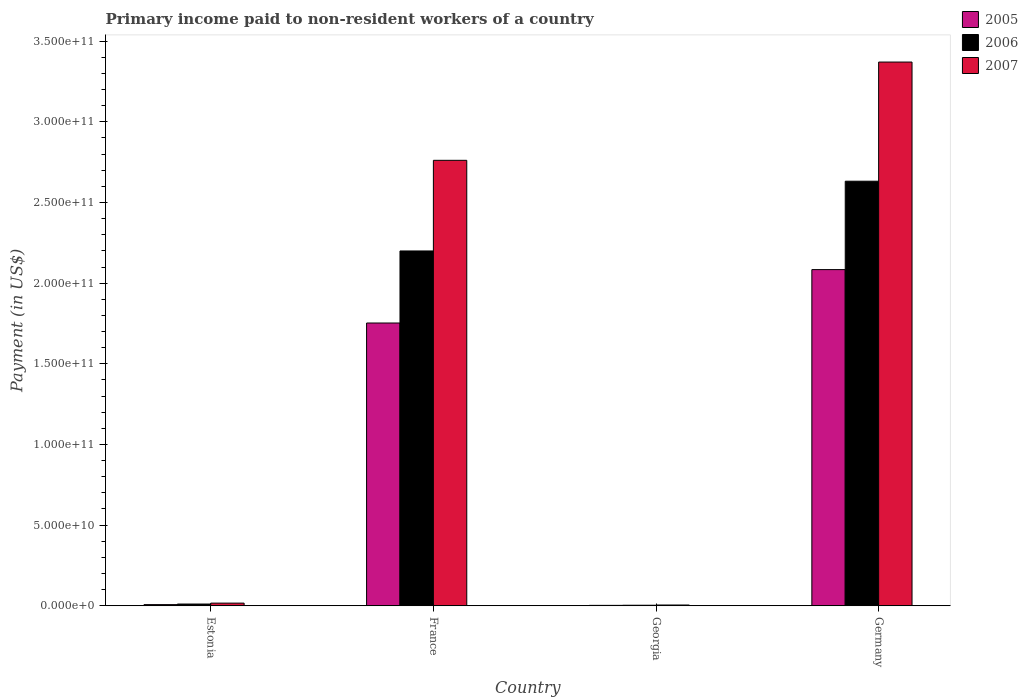Are the number of bars per tick equal to the number of legend labels?
Provide a short and direct response. Yes. How many bars are there on the 4th tick from the right?
Provide a succinct answer. 3. What is the label of the 1st group of bars from the left?
Give a very brief answer. Estonia. In how many cases, is the number of bars for a given country not equal to the number of legend labels?
Give a very brief answer. 0. What is the amount paid to workers in 2006 in Estonia?
Offer a terse response. 1.09e+09. Across all countries, what is the maximum amount paid to workers in 2006?
Provide a short and direct response. 2.63e+11. Across all countries, what is the minimum amount paid to workers in 2005?
Offer a very short reply. 2.63e+08. In which country was the amount paid to workers in 2007 minimum?
Offer a very short reply. Georgia. What is the total amount paid to workers in 2007 in the graph?
Give a very brief answer. 6.15e+11. What is the difference between the amount paid to workers in 2006 in Georgia and that in Germany?
Your response must be concise. -2.63e+11. What is the difference between the amount paid to workers in 2006 in Georgia and the amount paid to workers in 2005 in France?
Offer a terse response. -1.75e+11. What is the average amount paid to workers in 2005 per country?
Offer a terse response. 9.62e+1. What is the difference between the amount paid to workers of/in 2006 and amount paid to workers of/in 2007 in Georgia?
Offer a very short reply. -1.41e+08. What is the ratio of the amount paid to workers in 2006 in France to that in Germany?
Your answer should be very brief. 0.84. What is the difference between the highest and the second highest amount paid to workers in 2007?
Keep it short and to the point. 6.09e+1. What is the difference between the highest and the lowest amount paid to workers in 2007?
Your response must be concise. 3.37e+11. Is the sum of the amount paid to workers in 2005 in Estonia and Georgia greater than the maximum amount paid to workers in 2006 across all countries?
Your response must be concise. No. Is it the case that in every country, the sum of the amount paid to workers in 2005 and amount paid to workers in 2006 is greater than the amount paid to workers in 2007?
Offer a terse response. Yes. Are all the bars in the graph horizontal?
Keep it short and to the point. No. What is the difference between two consecutive major ticks on the Y-axis?
Offer a very short reply. 5.00e+1. Does the graph contain grids?
Make the answer very short. No. Where does the legend appear in the graph?
Provide a short and direct response. Top right. How many legend labels are there?
Your answer should be very brief. 3. What is the title of the graph?
Make the answer very short. Primary income paid to non-resident workers of a country. Does "1992" appear as one of the legend labels in the graph?
Offer a terse response. No. What is the label or title of the Y-axis?
Your answer should be compact. Payment (in US$). What is the Payment (in US$) in 2005 in Estonia?
Make the answer very short. 7.31e+08. What is the Payment (in US$) in 2006 in Estonia?
Offer a terse response. 1.09e+09. What is the Payment (in US$) in 2007 in Estonia?
Provide a succinct answer. 1.66e+09. What is the Payment (in US$) of 2005 in France?
Provide a succinct answer. 1.75e+11. What is the Payment (in US$) of 2006 in France?
Provide a short and direct response. 2.20e+11. What is the Payment (in US$) of 2007 in France?
Provide a short and direct response. 2.76e+11. What is the Payment (in US$) in 2005 in Georgia?
Ensure brevity in your answer.  2.63e+08. What is the Payment (in US$) in 2006 in Georgia?
Keep it short and to the point. 3.41e+08. What is the Payment (in US$) in 2007 in Georgia?
Provide a succinct answer. 4.83e+08. What is the Payment (in US$) of 2005 in Germany?
Provide a succinct answer. 2.08e+11. What is the Payment (in US$) of 2006 in Germany?
Your answer should be very brief. 2.63e+11. What is the Payment (in US$) of 2007 in Germany?
Offer a very short reply. 3.37e+11. Across all countries, what is the maximum Payment (in US$) in 2005?
Your answer should be compact. 2.08e+11. Across all countries, what is the maximum Payment (in US$) in 2006?
Ensure brevity in your answer.  2.63e+11. Across all countries, what is the maximum Payment (in US$) in 2007?
Make the answer very short. 3.37e+11. Across all countries, what is the minimum Payment (in US$) of 2005?
Give a very brief answer. 2.63e+08. Across all countries, what is the minimum Payment (in US$) in 2006?
Give a very brief answer. 3.41e+08. Across all countries, what is the minimum Payment (in US$) in 2007?
Your answer should be very brief. 4.83e+08. What is the total Payment (in US$) of 2005 in the graph?
Your answer should be compact. 3.85e+11. What is the total Payment (in US$) of 2006 in the graph?
Your answer should be very brief. 4.85e+11. What is the total Payment (in US$) in 2007 in the graph?
Your response must be concise. 6.15e+11. What is the difference between the Payment (in US$) in 2005 in Estonia and that in France?
Provide a succinct answer. -1.75e+11. What is the difference between the Payment (in US$) of 2006 in Estonia and that in France?
Offer a terse response. -2.19e+11. What is the difference between the Payment (in US$) of 2007 in Estonia and that in France?
Your answer should be compact. -2.74e+11. What is the difference between the Payment (in US$) of 2005 in Estonia and that in Georgia?
Make the answer very short. 4.67e+08. What is the difference between the Payment (in US$) in 2006 in Estonia and that in Georgia?
Keep it short and to the point. 7.50e+08. What is the difference between the Payment (in US$) in 2007 in Estonia and that in Georgia?
Offer a terse response. 1.18e+09. What is the difference between the Payment (in US$) in 2005 in Estonia and that in Germany?
Offer a terse response. -2.08e+11. What is the difference between the Payment (in US$) in 2006 in Estonia and that in Germany?
Provide a succinct answer. -2.62e+11. What is the difference between the Payment (in US$) in 2007 in Estonia and that in Germany?
Offer a very short reply. -3.35e+11. What is the difference between the Payment (in US$) of 2005 in France and that in Georgia?
Your response must be concise. 1.75e+11. What is the difference between the Payment (in US$) of 2006 in France and that in Georgia?
Your answer should be compact. 2.20e+11. What is the difference between the Payment (in US$) of 2007 in France and that in Georgia?
Your answer should be very brief. 2.76e+11. What is the difference between the Payment (in US$) of 2005 in France and that in Germany?
Ensure brevity in your answer.  -3.31e+1. What is the difference between the Payment (in US$) of 2006 in France and that in Germany?
Your response must be concise. -4.32e+1. What is the difference between the Payment (in US$) of 2007 in France and that in Germany?
Make the answer very short. -6.09e+1. What is the difference between the Payment (in US$) of 2005 in Georgia and that in Germany?
Offer a terse response. -2.08e+11. What is the difference between the Payment (in US$) of 2006 in Georgia and that in Germany?
Your response must be concise. -2.63e+11. What is the difference between the Payment (in US$) of 2007 in Georgia and that in Germany?
Give a very brief answer. -3.37e+11. What is the difference between the Payment (in US$) in 2005 in Estonia and the Payment (in US$) in 2006 in France?
Offer a very short reply. -2.19e+11. What is the difference between the Payment (in US$) in 2005 in Estonia and the Payment (in US$) in 2007 in France?
Offer a very short reply. -2.75e+11. What is the difference between the Payment (in US$) of 2006 in Estonia and the Payment (in US$) of 2007 in France?
Keep it short and to the point. -2.75e+11. What is the difference between the Payment (in US$) of 2005 in Estonia and the Payment (in US$) of 2006 in Georgia?
Give a very brief answer. 3.90e+08. What is the difference between the Payment (in US$) of 2005 in Estonia and the Payment (in US$) of 2007 in Georgia?
Offer a terse response. 2.48e+08. What is the difference between the Payment (in US$) in 2006 in Estonia and the Payment (in US$) in 2007 in Georgia?
Ensure brevity in your answer.  6.09e+08. What is the difference between the Payment (in US$) in 2005 in Estonia and the Payment (in US$) in 2006 in Germany?
Your answer should be very brief. -2.62e+11. What is the difference between the Payment (in US$) in 2005 in Estonia and the Payment (in US$) in 2007 in Germany?
Provide a succinct answer. -3.36e+11. What is the difference between the Payment (in US$) in 2006 in Estonia and the Payment (in US$) in 2007 in Germany?
Give a very brief answer. -3.36e+11. What is the difference between the Payment (in US$) in 2005 in France and the Payment (in US$) in 2006 in Georgia?
Your response must be concise. 1.75e+11. What is the difference between the Payment (in US$) in 2005 in France and the Payment (in US$) in 2007 in Georgia?
Your answer should be very brief. 1.75e+11. What is the difference between the Payment (in US$) of 2006 in France and the Payment (in US$) of 2007 in Georgia?
Provide a short and direct response. 2.19e+11. What is the difference between the Payment (in US$) in 2005 in France and the Payment (in US$) in 2006 in Germany?
Keep it short and to the point. -8.79e+1. What is the difference between the Payment (in US$) in 2005 in France and the Payment (in US$) in 2007 in Germany?
Your answer should be compact. -1.62e+11. What is the difference between the Payment (in US$) in 2006 in France and the Payment (in US$) in 2007 in Germany?
Make the answer very short. -1.17e+11. What is the difference between the Payment (in US$) in 2005 in Georgia and the Payment (in US$) in 2006 in Germany?
Keep it short and to the point. -2.63e+11. What is the difference between the Payment (in US$) of 2005 in Georgia and the Payment (in US$) of 2007 in Germany?
Make the answer very short. -3.37e+11. What is the difference between the Payment (in US$) in 2006 in Georgia and the Payment (in US$) in 2007 in Germany?
Ensure brevity in your answer.  -3.37e+11. What is the average Payment (in US$) in 2005 per country?
Make the answer very short. 9.62e+1. What is the average Payment (in US$) in 2006 per country?
Offer a very short reply. 1.21e+11. What is the average Payment (in US$) of 2007 per country?
Your answer should be very brief. 1.54e+11. What is the difference between the Payment (in US$) in 2005 and Payment (in US$) in 2006 in Estonia?
Ensure brevity in your answer.  -3.61e+08. What is the difference between the Payment (in US$) in 2005 and Payment (in US$) in 2007 in Estonia?
Your response must be concise. -9.32e+08. What is the difference between the Payment (in US$) in 2006 and Payment (in US$) in 2007 in Estonia?
Provide a succinct answer. -5.71e+08. What is the difference between the Payment (in US$) of 2005 and Payment (in US$) of 2006 in France?
Provide a short and direct response. -4.47e+1. What is the difference between the Payment (in US$) of 2005 and Payment (in US$) of 2007 in France?
Your answer should be very brief. -1.01e+11. What is the difference between the Payment (in US$) in 2006 and Payment (in US$) in 2007 in France?
Provide a succinct answer. -5.62e+1. What is the difference between the Payment (in US$) in 2005 and Payment (in US$) in 2006 in Georgia?
Your answer should be very brief. -7.79e+07. What is the difference between the Payment (in US$) in 2005 and Payment (in US$) in 2007 in Georgia?
Provide a succinct answer. -2.19e+08. What is the difference between the Payment (in US$) of 2006 and Payment (in US$) of 2007 in Georgia?
Ensure brevity in your answer.  -1.41e+08. What is the difference between the Payment (in US$) in 2005 and Payment (in US$) in 2006 in Germany?
Keep it short and to the point. -5.48e+1. What is the difference between the Payment (in US$) in 2005 and Payment (in US$) in 2007 in Germany?
Your answer should be very brief. -1.29e+11. What is the difference between the Payment (in US$) in 2006 and Payment (in US$) in 2007 in Germany?
Keep it short and to the point. -7.39e+1. What is the ratio of the Payment (in US$) of 2005 in Estonia to that in France?
Offer a very short reply. 0. What is the ratio of the Payment (in US$) of 2006 in Estonia to that in France?
Keep it short and to the point. 0.01. What is the ratio of the Payment (in US$) in 2007 in Estonia to that in France?
Your answer should be compact. 0.01. What is the ratio of the Payment (in US$) in 2005 in Estonia to that in Georgia?
Keep it short and to the point. 2.77. What is the ratio of the Payment (in US$) of 2006 in Estonia to that in Georgia?
Provide a short and direct response. 3.2. What is the ratio of the Payment (in US$) of 2007 in Estonia to that in Georgia?
Provide a short and direct response. 3.45. What is the ratio of the Payment (in US$) in 2005 in Estonia to that in Germany?
Ensure brevity in your answer.  0. What is the ratio of the Payment (in US$) of 2006 in Estonia to that in Germany?
Ensure brevity in your answer.  0. What is the ratio of the Payment (in US$) in 2007 in Estonia to that in Germany?
Give a very brief answer. 0. What is the ratio of the Payment (in US$) of 2005 in France to that in Georgia?
Provide a short and direct response. 665.66. What is the ratio of the Payment (in US$) in 2006 in France to that in Georgia?
Your answer should be compact. 644.61. What is the ratio of the Payment (in US$) of 2007 in France to that in Georgia?
Your response must be concise. 572.29. What is the ratio of the Payment (in US$) of 2005 in France to that in Germany?
Keep it short and to the point. 0.84. What is the ratio of the Payment (in US$) of 2006 in France to that in Germany?
Make the answer very short. 0.84. What is the ratio of the Payment (in US$) in 2007 in France to that in Germany?
Your response must be concise. 0.82. What is the ratio of the Payment (in US$) of 2005 in Georgia to that in Germany?
Offer a terse response. 0. What is the ratio of the Payment (in US$) in 2006 in Georgia to that in Germany?
Offer a very short reply. 0. What is the ratio of the Payment (in US$) in 2007 in Georgia to that in Germany?
Provide a short and direct response. 0. What is the difference between the highest and the second highest Payment (in US$) of 2005?
Make the answer very short. 3.31e+1. What is the difference between the highest and the second highest Payment (in US$) in 2006?
Ensure brevity in your answer.  4.32e+1. What is the difference between the highest and the second highest Payment (in US$) of 2007?
Your response must be concise. 6.09e+1. What is the difference between the highest and the lowest Payment (in US$) of 2005?
Give a very brief answer. 2.08e+11. What is the difference between the highest and the lowest Payment (in US$) of 2006?
Offer a very short reply. 2.63e+11. What is the difference between the highest and the lowest Payment (in US$) of 2007?
Provide a short and direct response. 3.37e+11. 